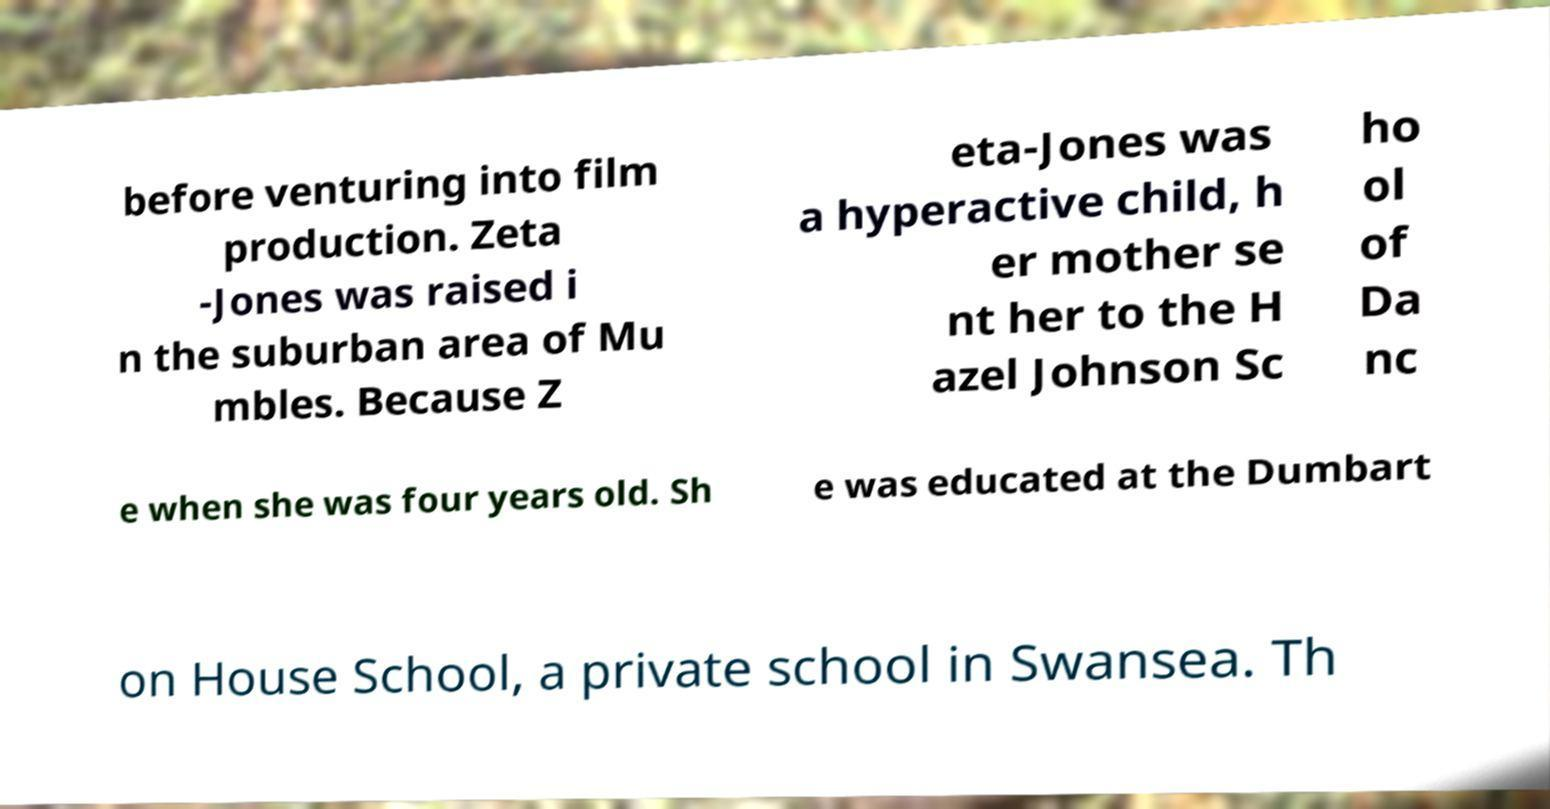What messages or text are displayed in this image? I need them in a readable, typed format. before venturing into film production. Zeta -Jones was raised i n the suburban area of Mu mbles. Because Z eta-Jones was a hyperactive child, h er mother se nt her to the H azel Johnson Sc ho ol of Da nc e when she was four years old. Sh e was educated at the Dumbart on House School, a private school in Swansea. Th 